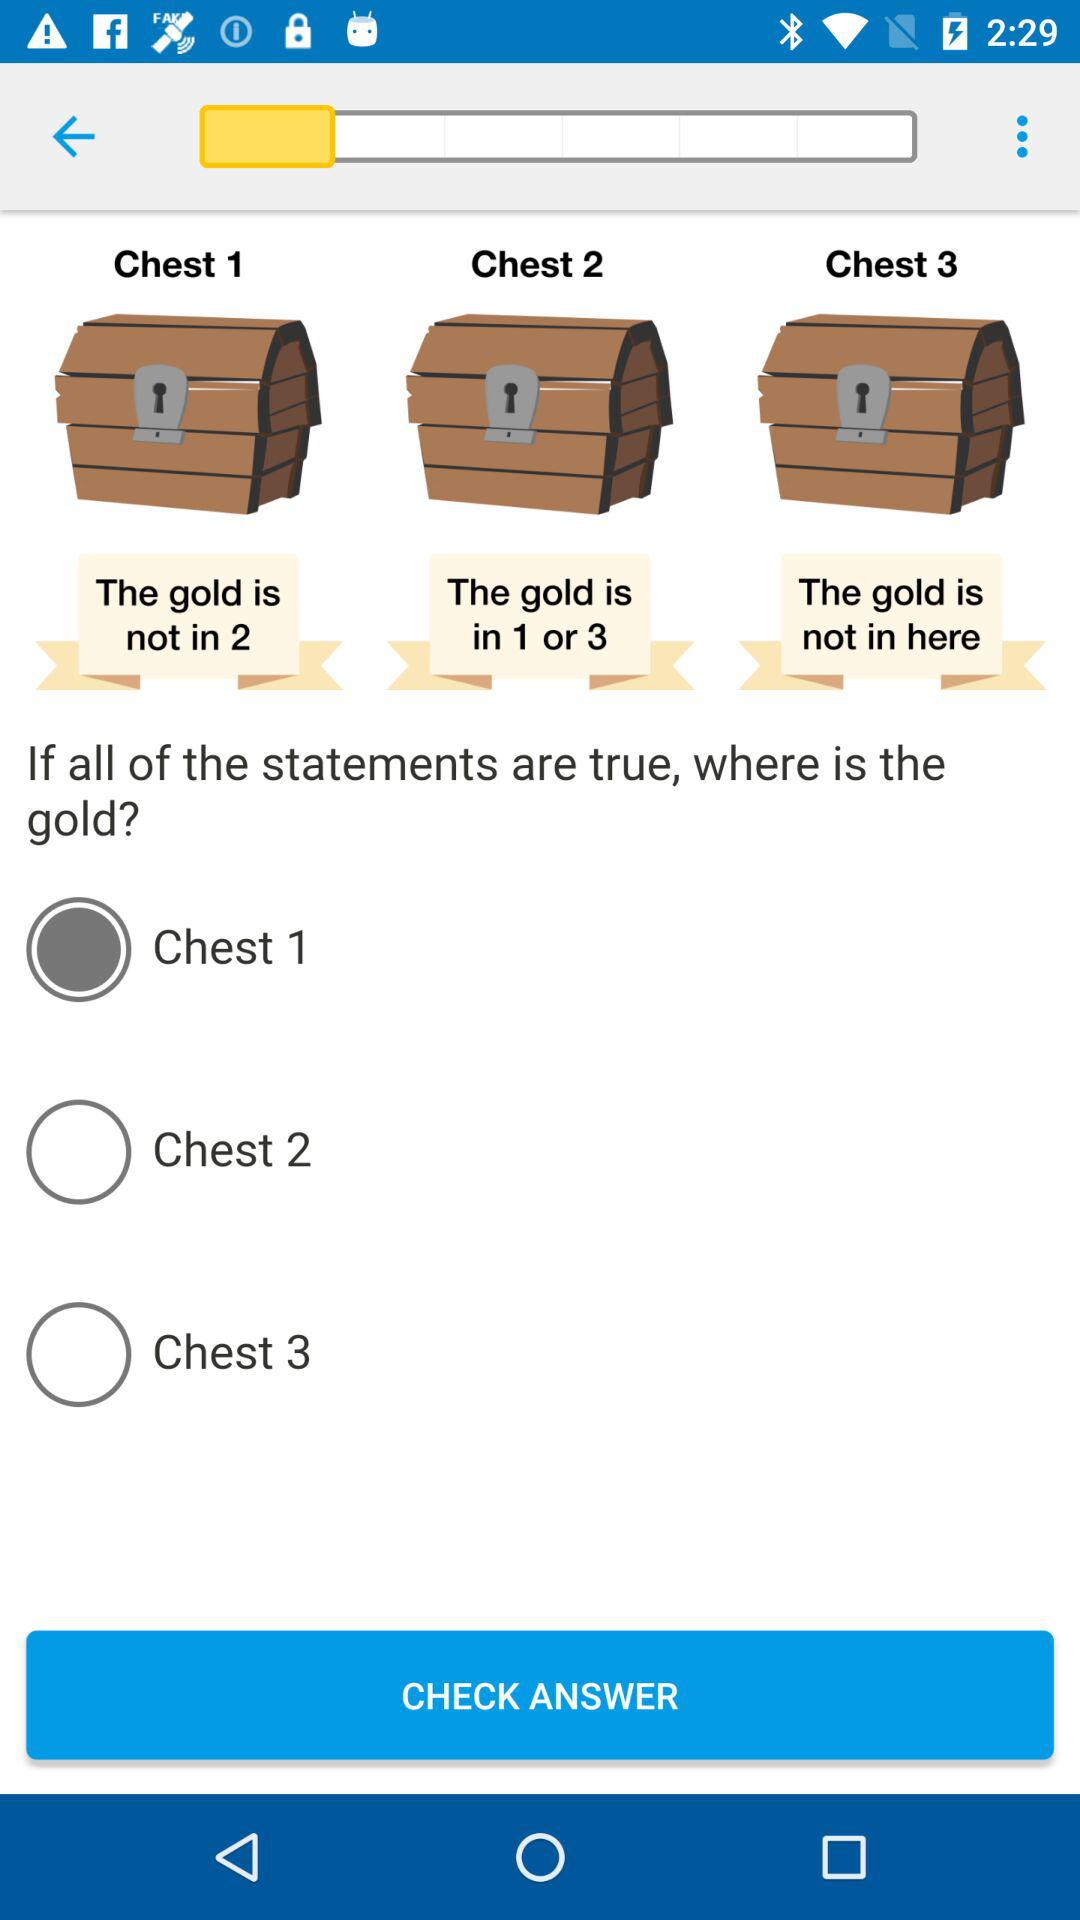How many chests do not contain gold?
Answer the question using a single word or phrase. 2 